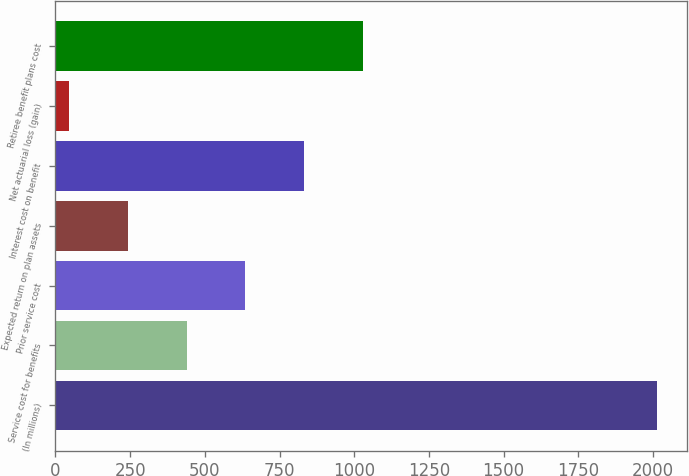<chart> <loc_0><loc_0><loc_500><loc_500><bar_chart><fcel>(In millions)<fcel>Service cost for benefits<fcel>Prior service cost<fcel>Expected return on plan assets<fcel>Interest cost on benefit<fcel>Net actuarial loss (gain)<fcel>Retiree benefit plans cost<nl><fcel>2013<fcel>438.6<fcel>635.4<fcel>241.8<fcel>832.2<fcel>45<fcel>1029<nl></chart> 